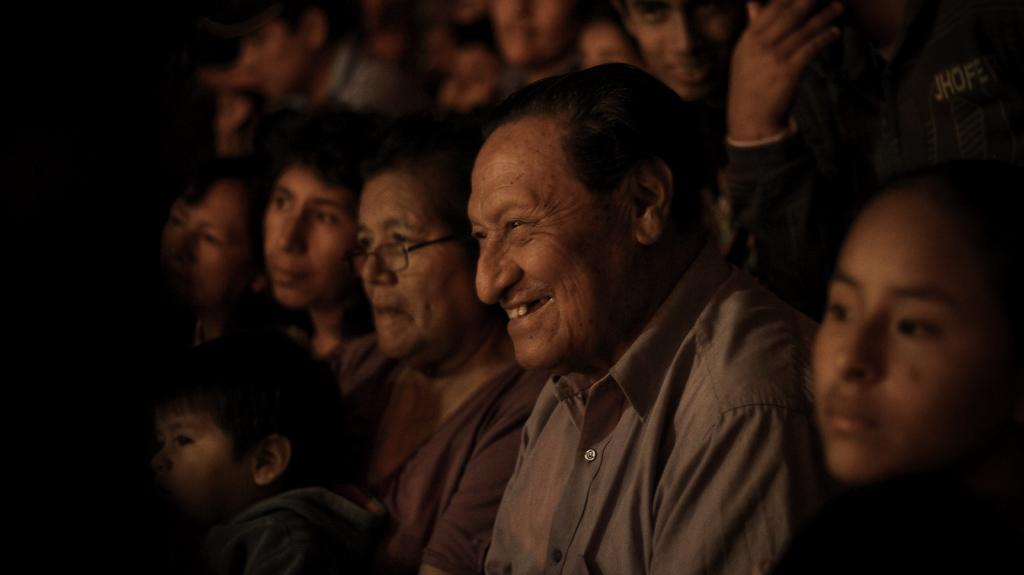How many people are in the image? There is a group of people in the image. What are the people in the image doing? The people are sitting. What expressions do the people have in the image? The people are smiling. What is the color of the background in the image? The background of the image is dark. What type of cloud can be seen in the image? There is no cloud present in the image. What page of the book are the people reading in the image? There is no book or page visible in the image. 